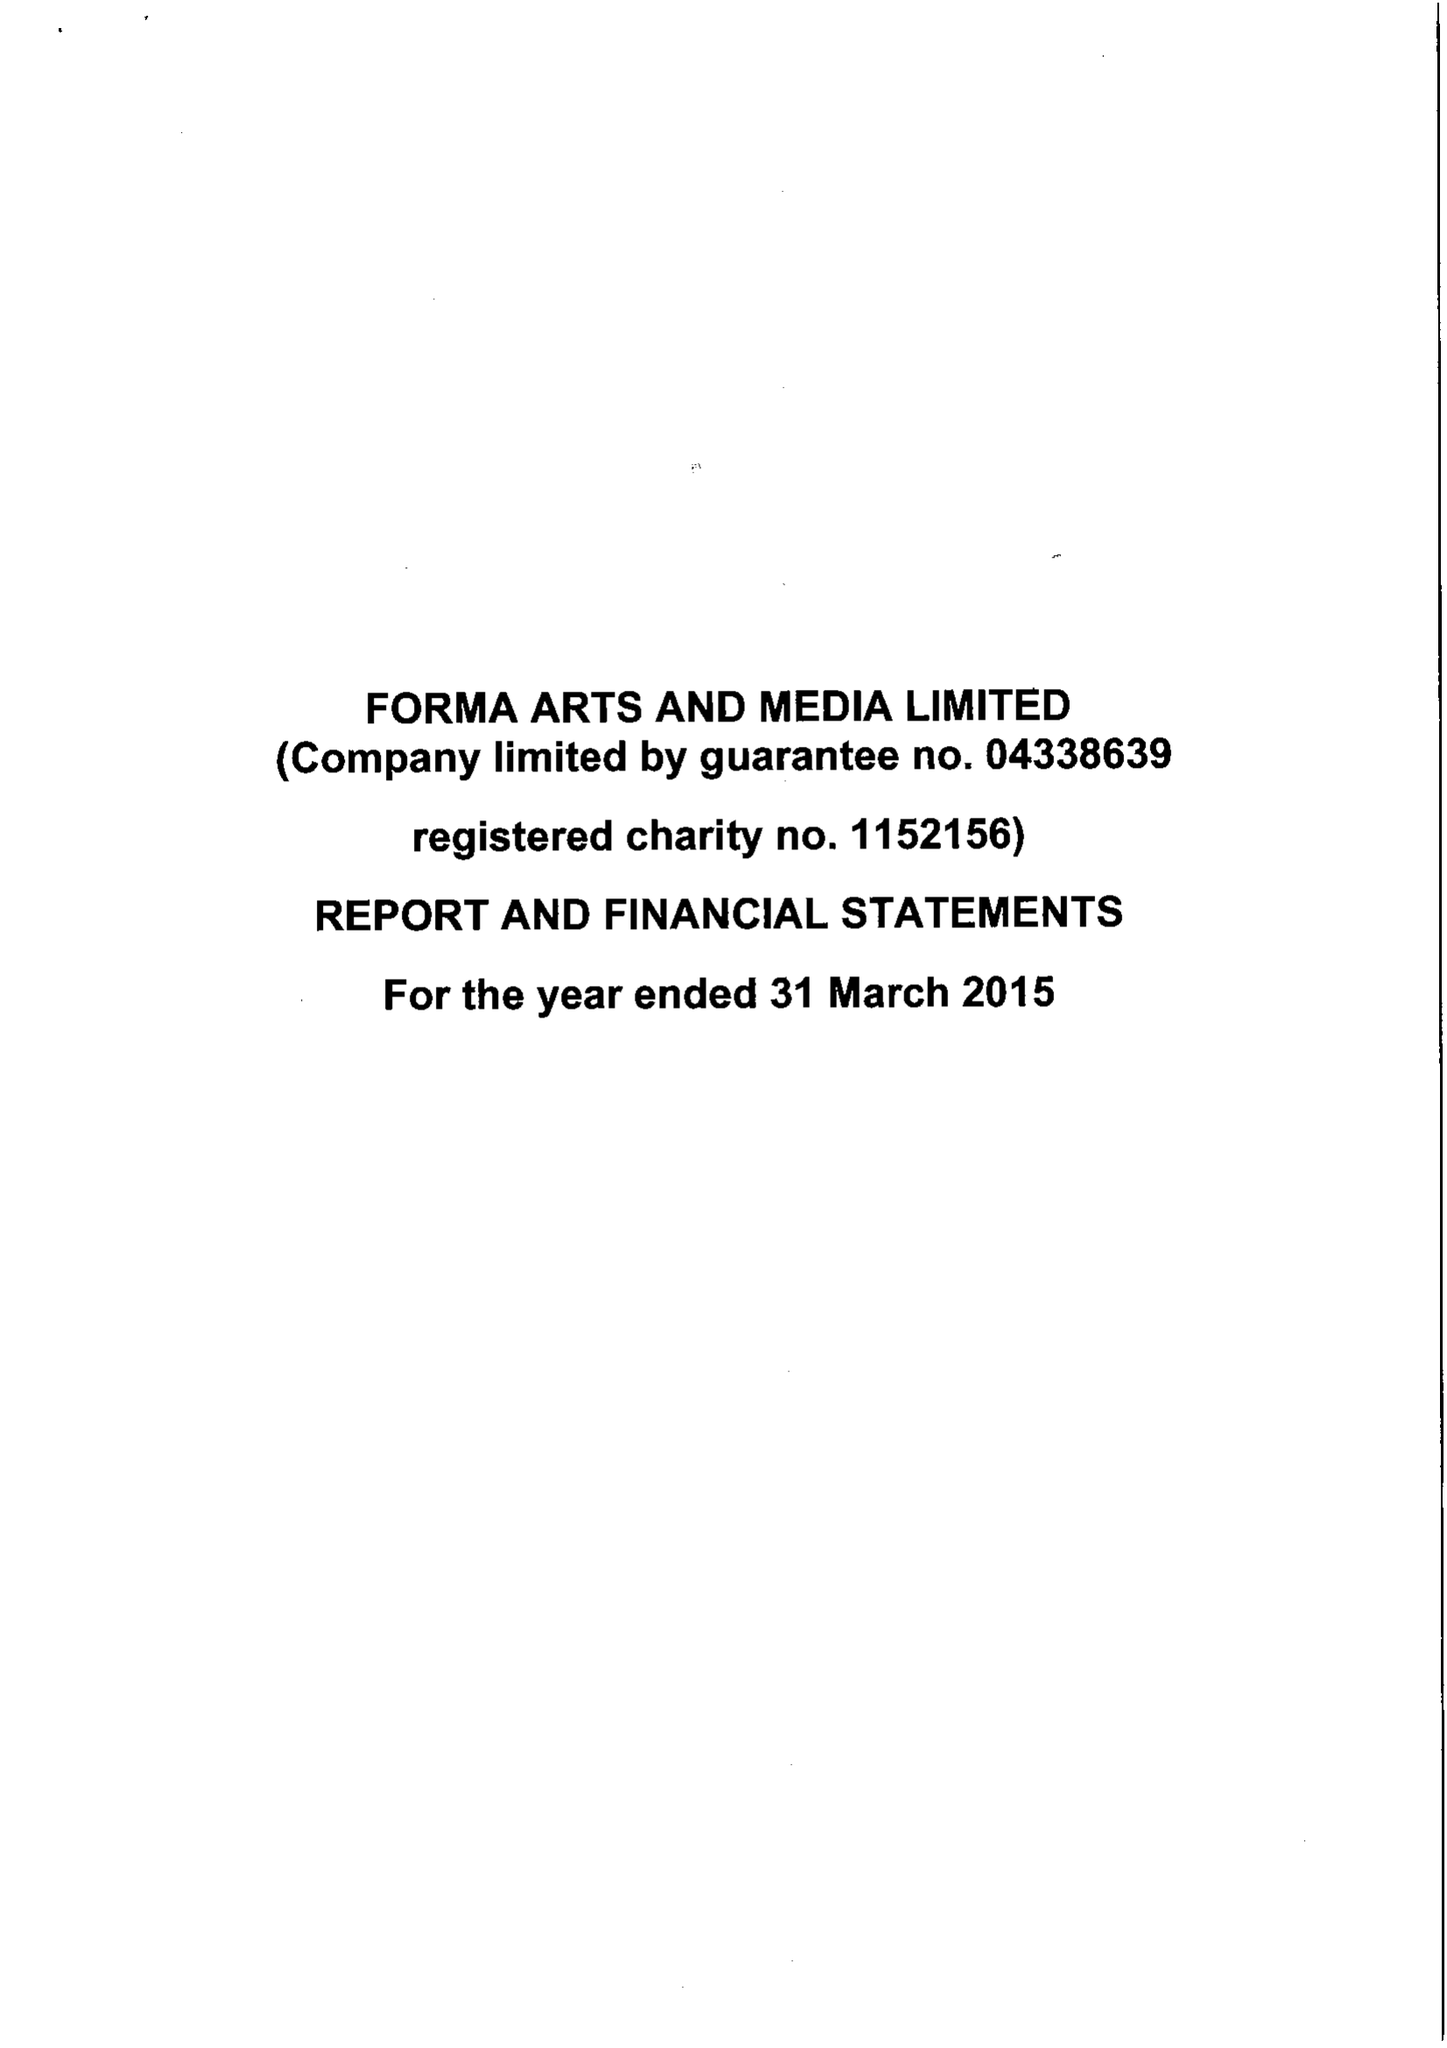What is the value for the charity_number?
Answer the question using a single word or phrase. 1152156 